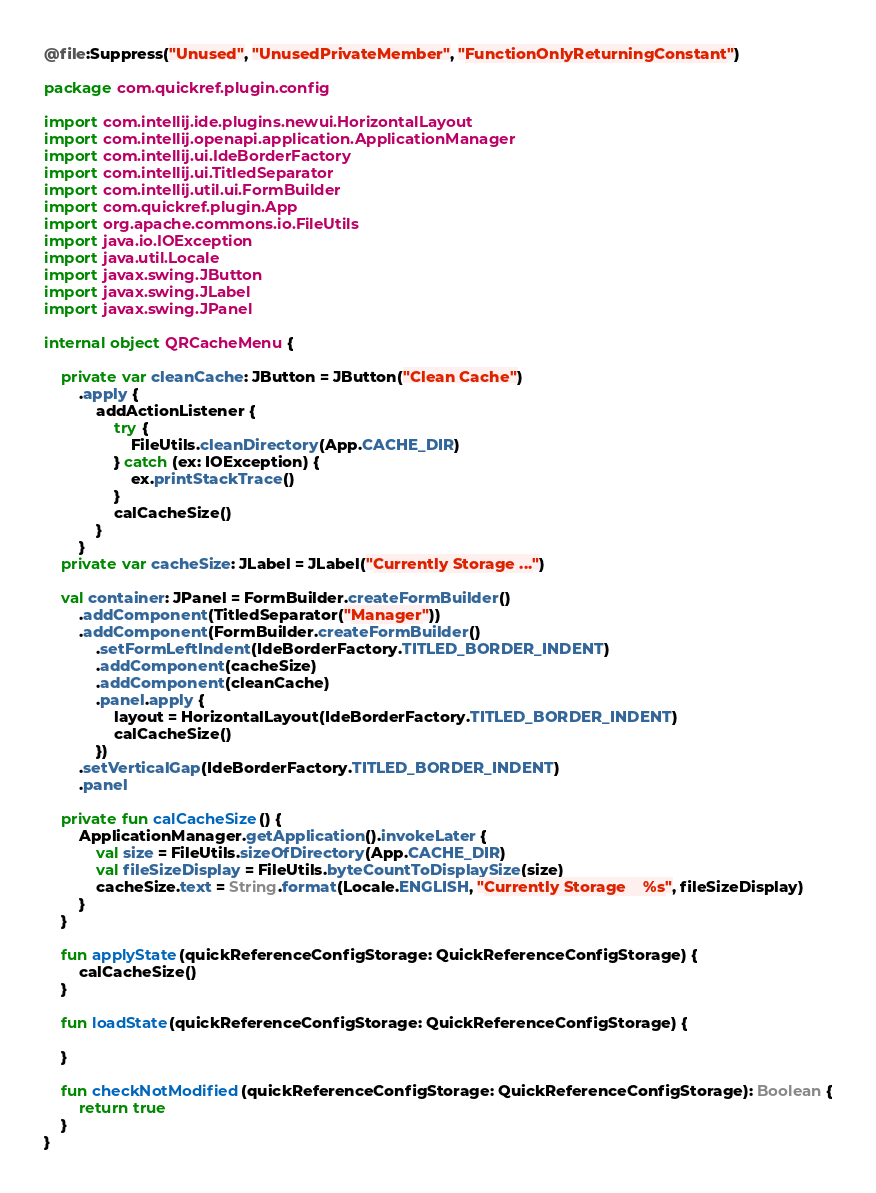<code> <loc_0><loc_0><loc_500><loc_500><_Kotlin_>@file:Suppress("Unused", "UnusedPrivateMember", "FunctionOnlyReturningConstant")

package com.quickref.plugin.config

import com.intellij.ide.plugins.newui.HorizontalLayout
import com.intellij.openapi.application.ApplicationManager
import com.intellij.ui.IdeBorderFactory
import com.intellij.ui.TitledSeparator
import com.intellij.util.ui.FormBuilder
import com.quickref.plugin.App
import org.apache.commons.io.FileUtils
import java.io.IOException
import java.util.Locale
import javax.swing.JButton
import javax.swing.JLabel
import javax.swing.JPanel

internal object QRCacheMenu {

    private var cleanCache: JButton = JButton("Clean Cache")
        .apply {
            addActionListener {
                try {
                    FileUtils.cleanDirectory(App.CACHE_DIR)
                } catch (ex: IOException) {
                    ex.printStackTrace()
                }
                calCacheSize()
            }
        }
    private var cacheSize: JLabel = JLabel("Currently Storage ...")

    val container: JPanel = FormBuilder.createFormBuilder()
        .addComponent(TitledSeparator("Manager"))
        .addComponent(FormBuilder.createFormBuilder()
            .setFormLeftIndent(IdeBorderFactory.TITLED_BORDER_INDENT)
            .addComponent(cacheSize)
            .addComponent(cleanCache)
            .panel.apply {
                layout = HorizontalLayout(IdeBorderFactory.TITLED_BORDER_INDENT)
                calCacheSize()
            })
        .setVerticalGap(IdeBorderFactory.TITLED_BORDER_INDENT)
        .panel

    private fun calCacheSize() {
        ApplicationManager.getApplication().invokeLater {
            val size = FileUtils.sizeOfDirectory(App.CACHE_DIR)
            val fileSizeDisplay = FileUtils.byteCountToDisplaySize(size)
            cacheSize.text = String.format(Locale.ENGLISH, "Currently Storage    %s", fileSizeDisplay)
        }
    }

    fun applyState(quickReferenceConfigStorage: QuickReferenceConfigStorage) {
        calCacheSize()
    }

    fun loadState(quickReferenceConfigStorage: QuickReferenceConfigStorage) {

    }

    fun checkNotModified(quickReferenceConfigStorage: QuickReferenceConfigStorage): Boolean {
        return true
    }
}
</code> 